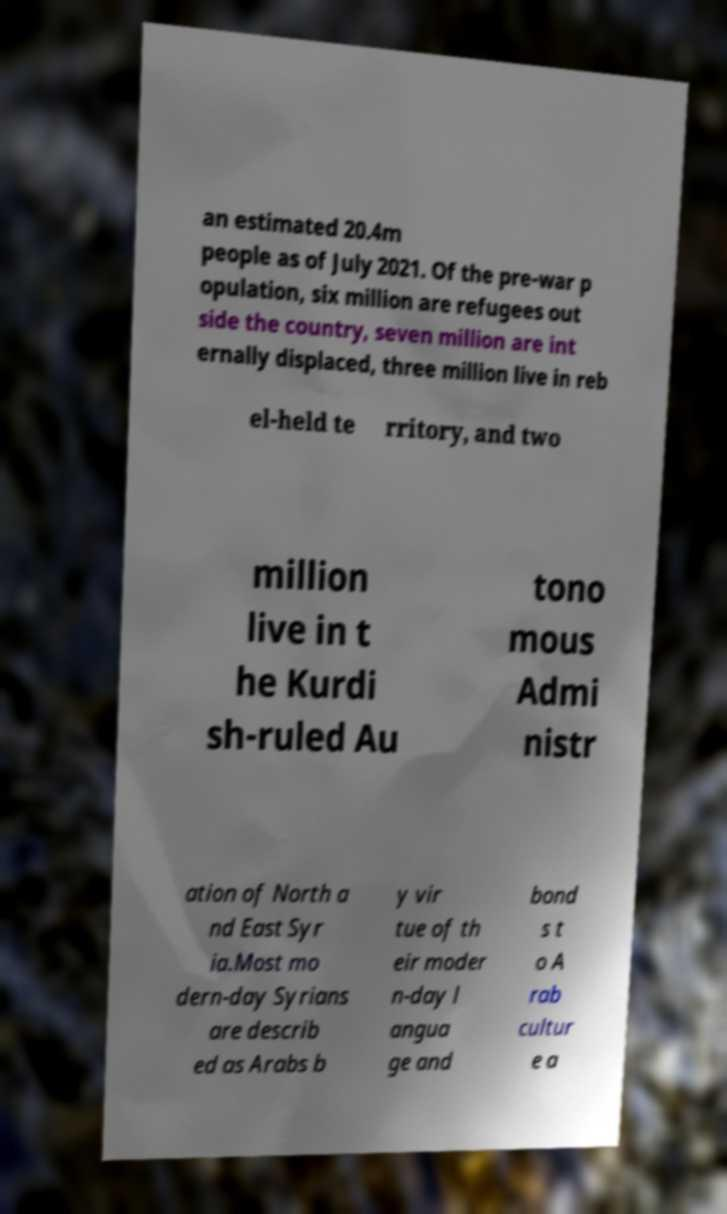Could you extract and type out the text from this image? an estimated 20.4m people as of July 2021. Of the pre-war p opulation, six million are refugees out side the country, seven million are int ernally displaced, three million live in reb el-held te rritory, and two million live in t he Kurdi sh-ruled Au tono mous Admi nistr ation of North a nd East Syr ia.Most mo dern-day Syrians are describ ed as Arabs b y vir tue of th eir moder n-day l angua ge and bond s t o A rab cultur e a 